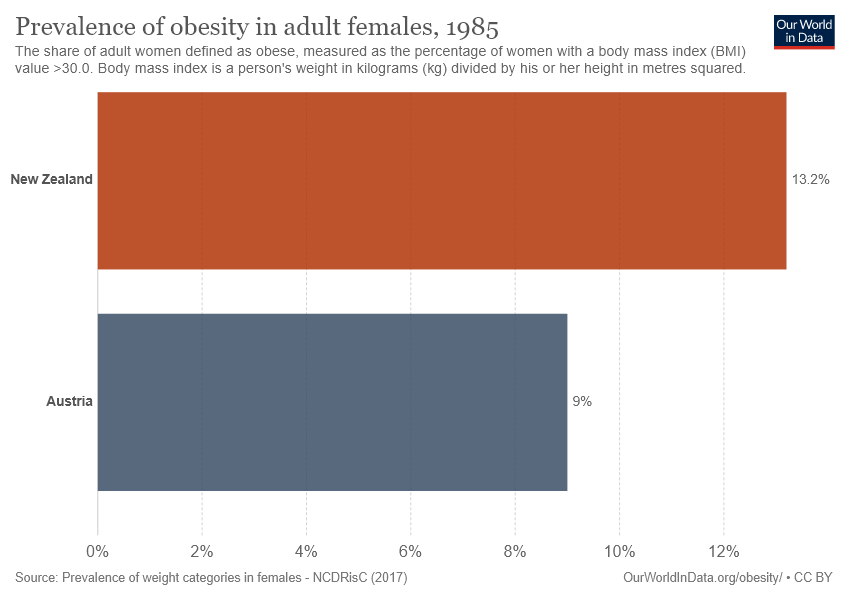Mention a couple of crucial points in this snapshot. New Zealand's percentage value is 13.2%. The difference between the orange and gray bars is greater than 2, indicating that this is the case. 